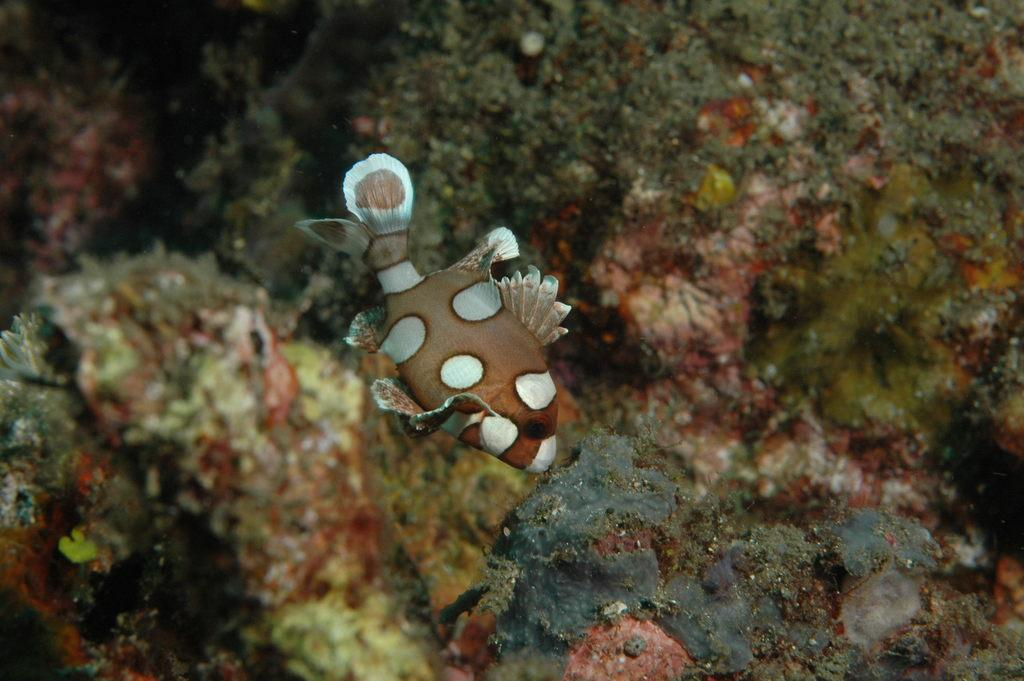What is the main subject of the image? There is a fish in the middle of the image. What can be seen in the background of the image? Sea plants are visible in the background of the image. What type of wax is used to create the knot in the image? There is no wax or knot present in the image; it features a fish and sea plants. 